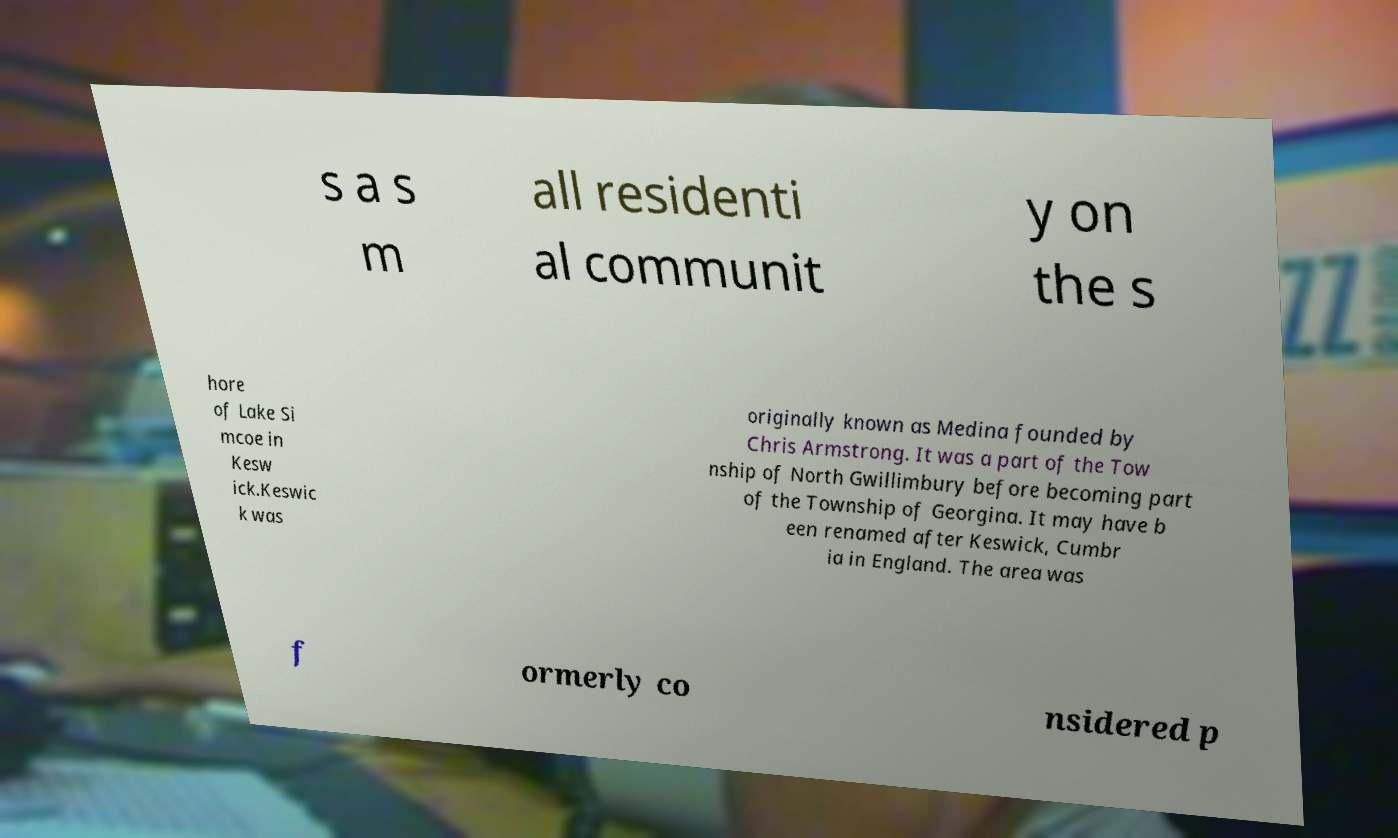Can you accurately transcribe the text from the provided image for me? s a s m all residenti al communit y on the s hore of Lake Si mcoe in Kesw ick.Keswic k was originally known as Medina founded by Chris Armstrong. It was a part of the Tow nship of North Gwillimbury before becoming part of the Township of Georgina. It may have b een renamed after Keswick, Cumbr ia in England. The area was f ormerly co nsidered p 